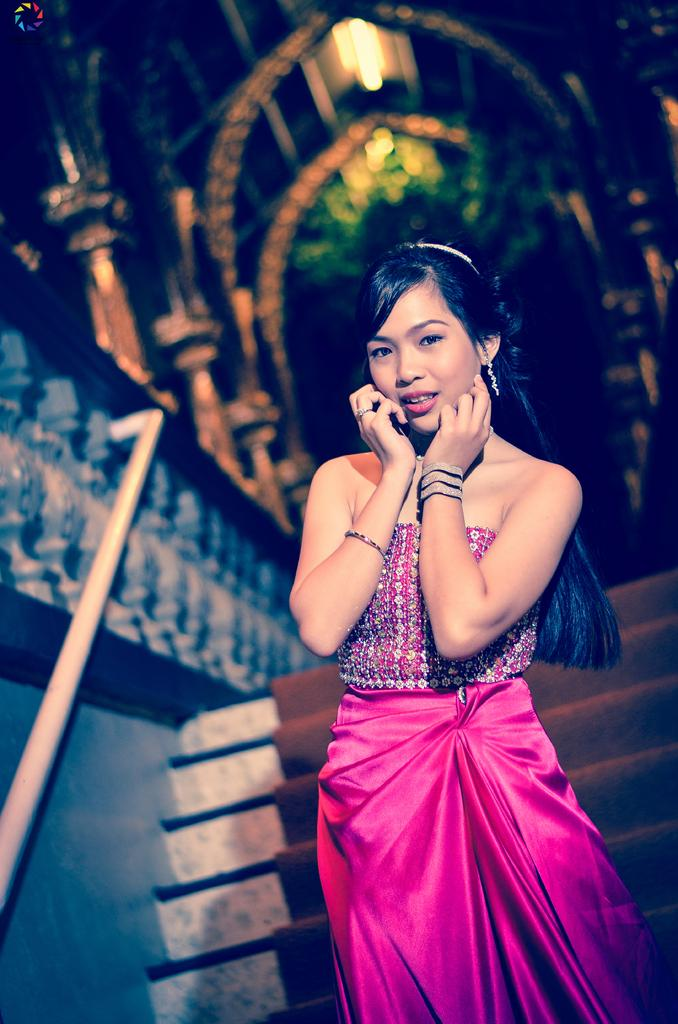What is the main subject of the image? There is a lady standing in the image. What is located behind the lady? There are steps behind the lady. Can you describe any specific features on the left side of the image? There is a handle on the left side of the image. How would you describe the background of the image? The background of the image is blurred. What architectural elements can be seen in the background? There are pillars, arches, and lights visible in the background. What type of flower is the lady holding in the image? There is no flower present in the image; the lady is not holding anything. What is the relation between the lady and the person standing next to her in the image? There is no other person visible in the image, so it is not possible to determine any relation between the lady and another person. 